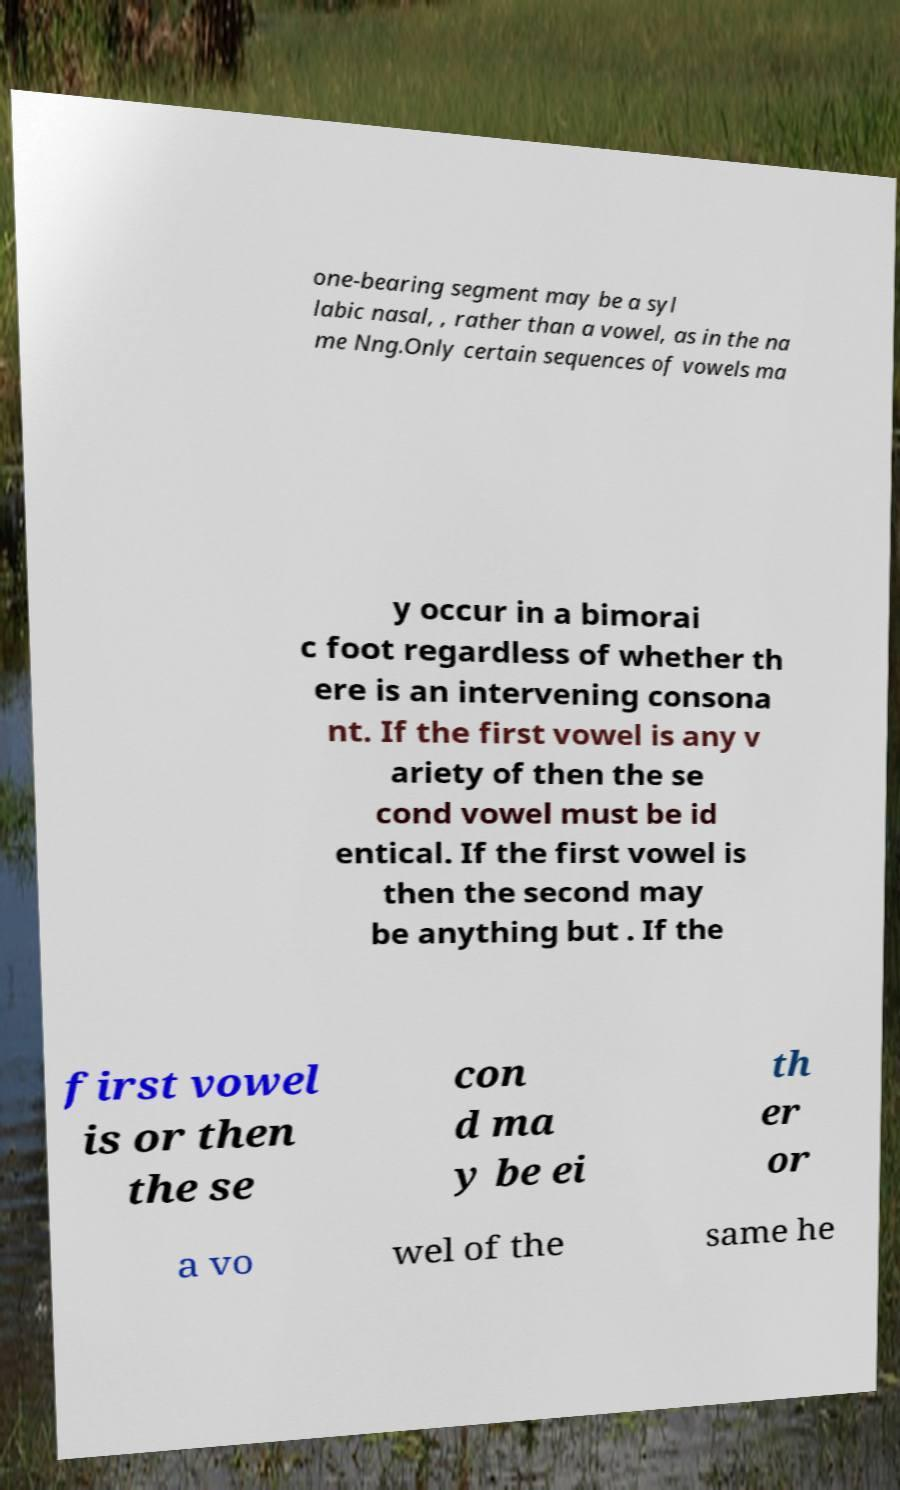What messages or text are displayed in this image? I need them in a readable, typed format. one-bearing segment may be a syl labic nasal, , rather than a vowel, as in the na me Nng.Only certain sequences of vowels ma y occur in a bimorai c foot regardless of whether th ere is an intervening consona nt. If the first vowel is any v ariety of then the se cond vowel must be id entical. If the first vowel is then the second may be anything but . If the first vowel is or then the se con d ma y be ei th er or a vo wel of the same he 